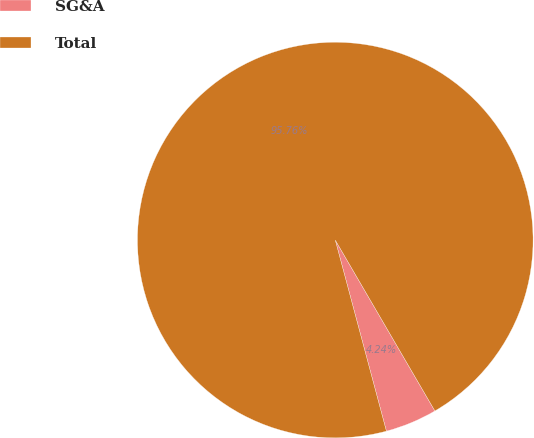Convert chart to OTSL. <chart><loc_0><loc_0><loc_500><loc_500><pie_chart><fcel>SG&A<fcel>Total<nl><fcel>4.24%<fcel>95.76%<nl></chart> 